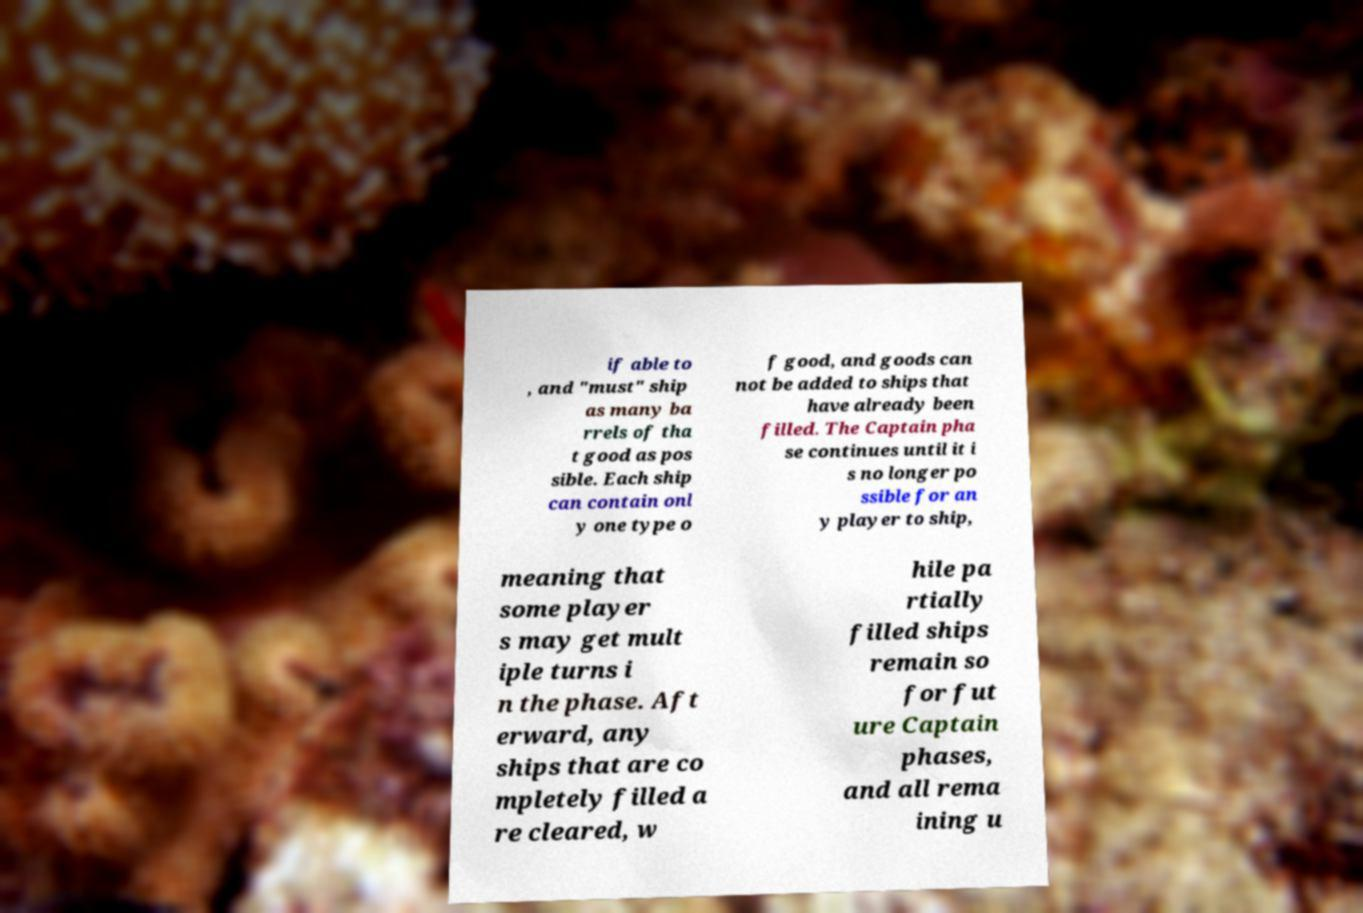There's text embedded in this image that I need extracted. Can you transcribe it verbatim? if able to , and "must" ship as many ba rrels of tha t good as pos sible. Each ship can contain onl y one type o f good, and goods can not be added to ships that have already been filled. The Captain pha se continues until it i s no longer po ssible for an y player to ship, meaning that some player s may get mult iple turns i n the phase. Aft erward, any ships that are co mpletely filled a re cleared, w hile pa rtially filled ships remain so for fut ure Captain phases, and all rema ining u 